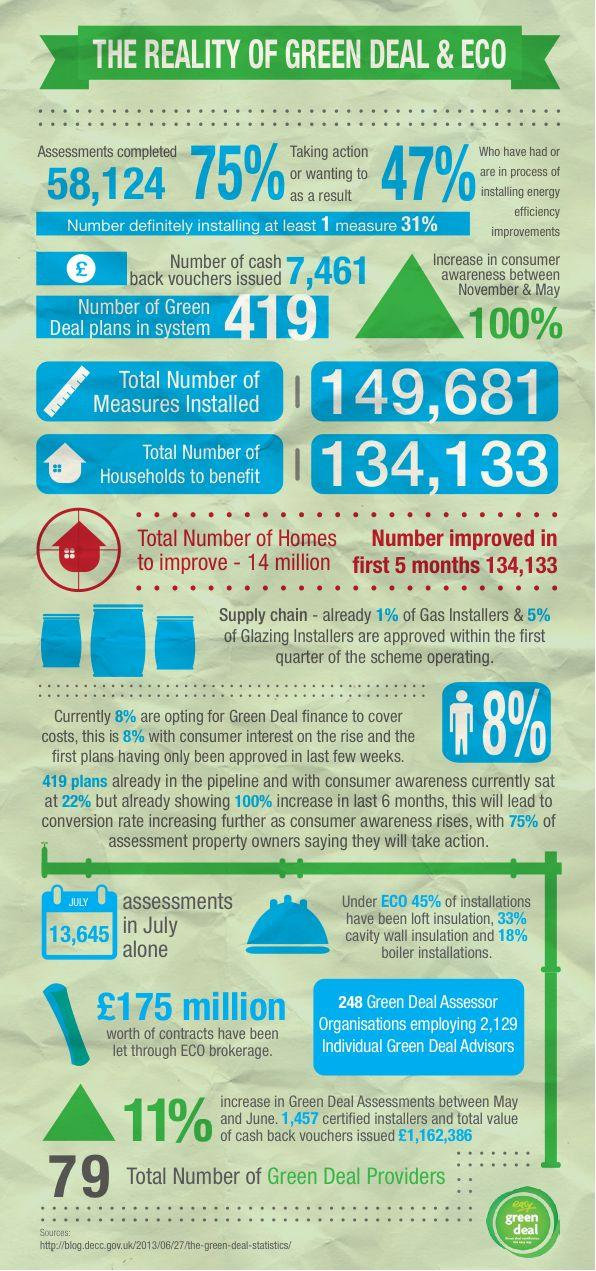Outline some significant characteristics in this image. There are 419 active Green Deal plans currently in the system. By November, consumer awareness about the green deal had reached 100%. By May, this awareness had increased by a significant percentage. In the month of July, a total of 13,645 green deal assessments were completed. As of the current date, a total of 58,124 green deal assessments have been completed. The number of cash back vouchers issued by green deal organizations is 7,461. 